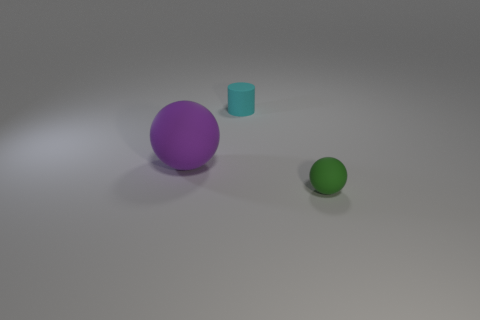The tiny rubber cylinder has what color?
Make the answer very short. Cyan. How big is the rubber thing that is both left of the tiny green matte object and on the right side of the big object?
Provide a short and direct response. Small. What number of objects are objects behind the large sphere or large blue things?
Offer a terse response. 1. There is a big object that is the same material as the tiny green ball; what shape is it?
Your response must be concise. Sphere. The purple rubber thing is what shape?
Give a very brief answer. Sphere. There is a thing that is both in front of the small cyan object and behind the small green ball; what is its color?
Provide a short and direct response. Purple. There is a green thing that is the same size as the cylinder; what is its shape?
Provide a short and direct response. Sphere. Are there any other rubber objects of the same shape as the green object?
Offer a terse response. Yes. The object in front of the sphere behind the small rubber thing that is to the right of the rubber cylinder is what color?
Provide a succinct answer. Green. What number of yellow cylinders are the same material as the small sphere?
Keep it short and to the point. 0. 